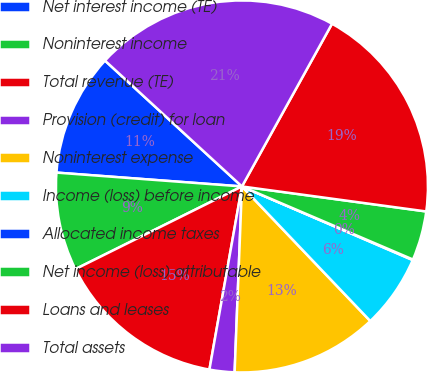Convert chart to OTSL. <chart><loc_0><loc_0><loc_500><loc_500><pie_chart><fcel>Net interest income (TE)<fcel>Noninterest income<fcel>Total revenue (TE)<fcel>Provision (credit) for loan<fcel>Noninterest expense<fcel>Income (loss) before income<fcel>Allocated income taxes<fcel>Net income (loss) attributable<fcel>Loans and leases<fcel>Total assets<nl><fcel>10.64%<fcel>8.52%<fcel>14.87%<fcel>2.17%<fcel>12.75%<fcel>6.4%<fcel>0.05%<fcel>4.28%<fcel>19.1%<fcel>21.22%<nl></chart> 